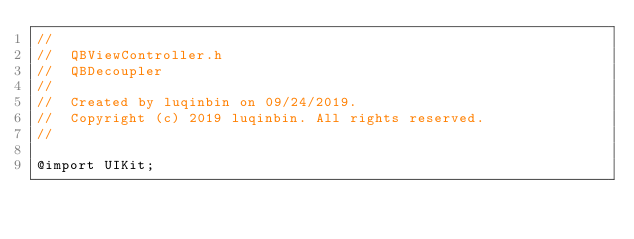<code> <loc_0><loc_0><loc_500><loc_500><_C_>//
//  QBViewController.h
//  QBDecoupler
//
//  Created by luqinbin on 09/24/2019.
//  Copyright (c) 2019 luqinbin. All rights reserved.
//

@import UIKit;
</code> 